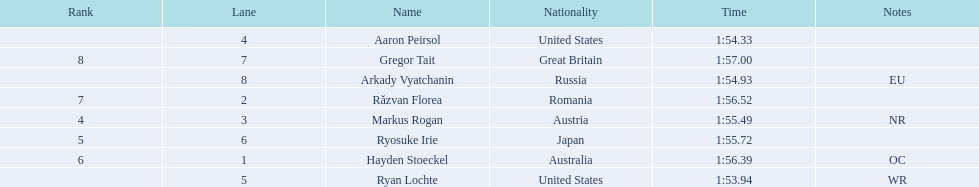Who participated in the event? Ryan Lochte, Aaron Peirsol, Arkady Vyatchanin, Markus Rogan, Ryosuke Irie, Hayden Stoeckel, Răzvan Florea, Gregor Tait. What was the finishing time of each athlete? 1:53.94, 1:54.33, 1:54.93, 1:55.49, 1:55.72, 1:56.39, 1:56.52, 1:57.00. How about just ryosuke irie? 1:55.72. 